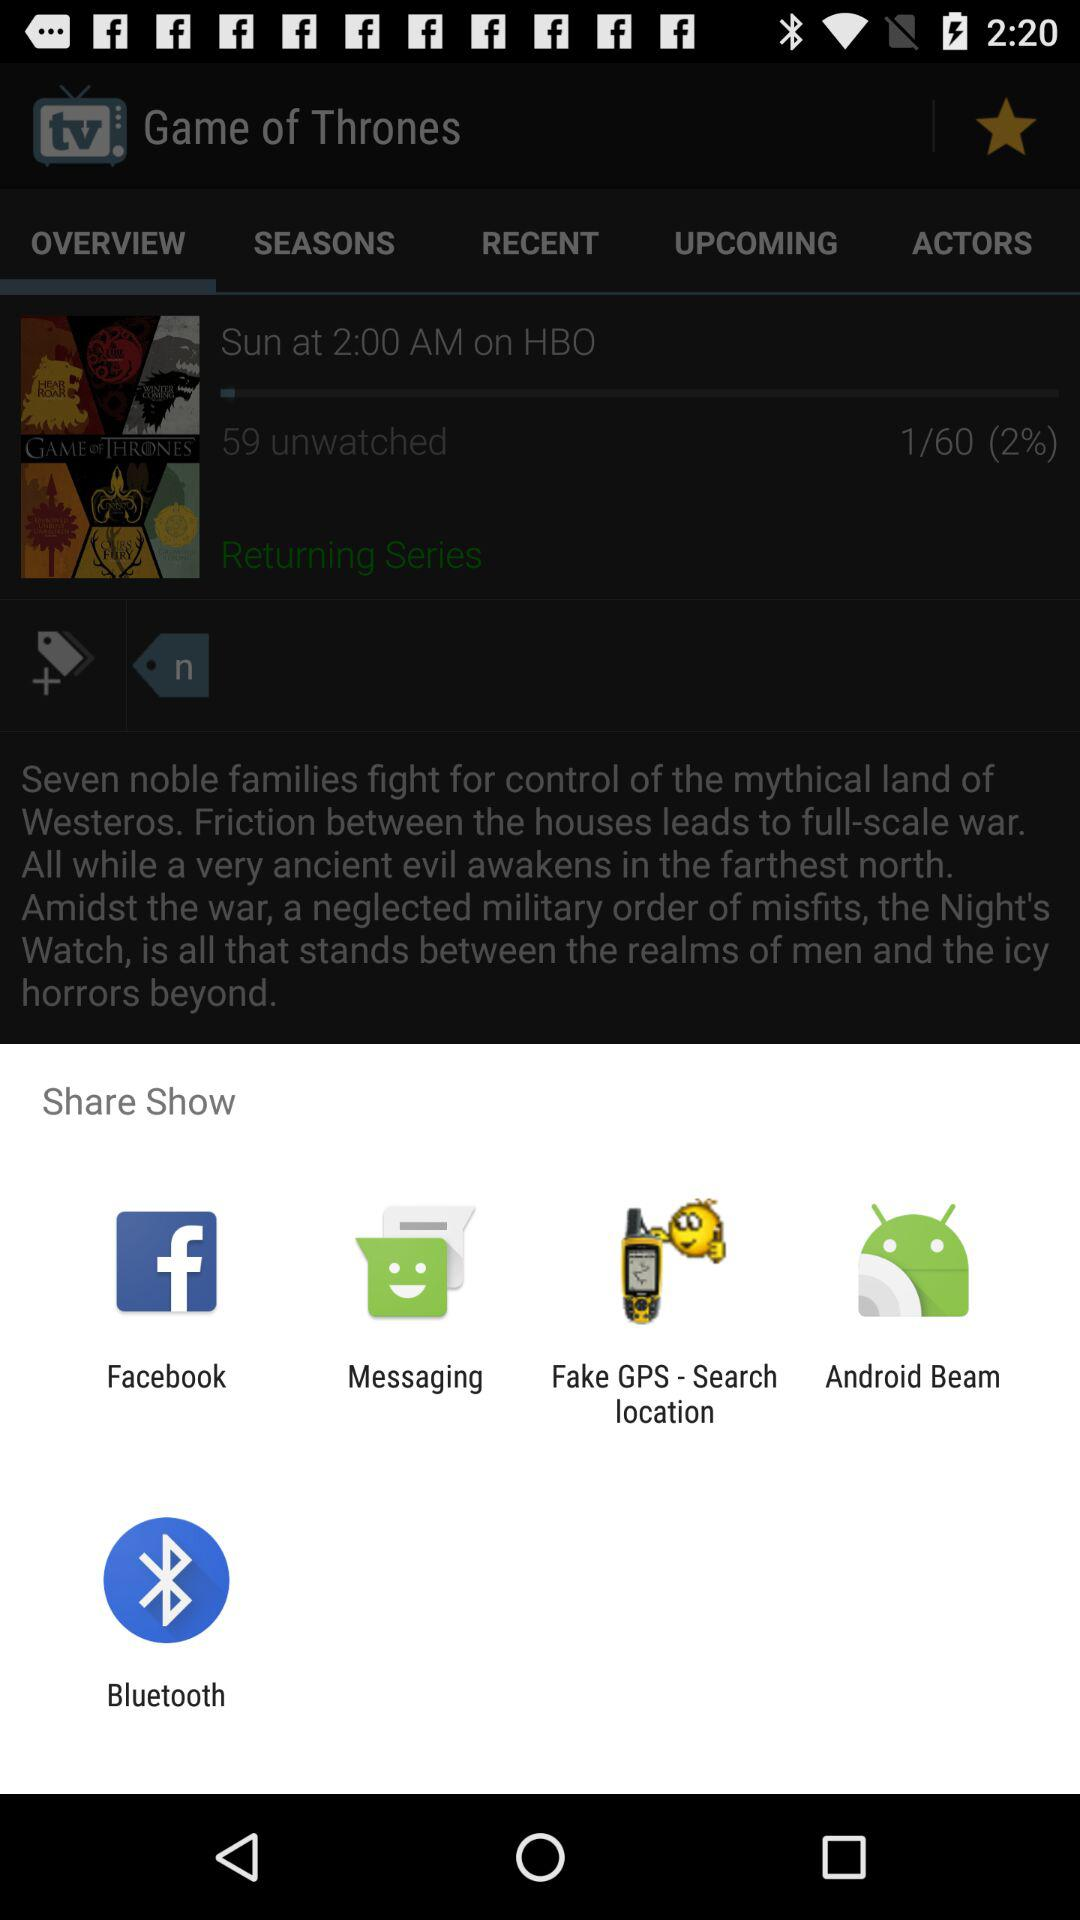What is the total number of videos? The total number is 60. 